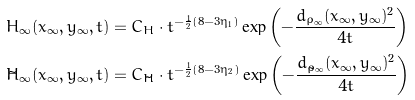<formula> <loc_0><loc_0><loc_500><loc_500>H _ { \infty } ( x _ { \infty } , y _ { \infty } , t ) & = C _ { H } \cdot t ^ { - \frac { 1 } { 2 } ( 8 - 3 \eta _ { 1 } ) } \exp { \left ( - \frac { d _ { \rho _ { \infty } } ( x _ { \infty } , y _ { \infty } ) ^ { 2 } } { 4 t } \right ) } \\ \tilde { H } _ { \infty } ( x _ { \infty } , y _ { \infty } , t ) & = C _ { \tilde { H } } \cdot t ^ { - \frac { 1 } { 2 } ( 8 - 3 \eta _ { 2 } ) } \exp { \left ( - \frac { d _ { \tilde { \rho } _ { \infty } } ( x _ { \infty } , y _ { \infty } ) ^ { 2 } } { 4 t } \right ) }</formula> 